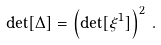<formula> <loc_0><loc_0><loc_500><loc_500>\det [ \Delta ] = \left ( \det [ \xi ^ { 1 } ] \right ) ^ { 2 } \, .</formula> 